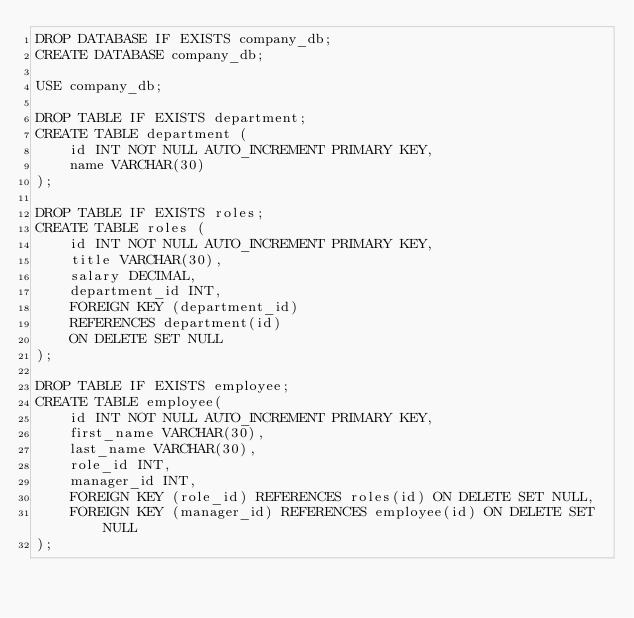<code> <loc_0><loc_0><loc_500><loc_500><_SQL_>DROP DATABASE IF EXISTS company_db;
CREATE DATABASE company_db;

USE company_db;

DROP TABLE IF EXISTS department;
CREATE TABLE department (
    id INT NOT NULL AUTO_INCREMENT PRIMARY KEY,
    name VARCHAR(30)
);

DROP TABLE IF EXISTS roles;
CREATE TABLE roles (
    id INT NOT NULL AUTO_INCREMENT PRIMARY KEY,
    title VARCHAR(30),
    salary DECIMAL,
    department_id INT,
    FOREIGN KEY (department_id)
    REFERENCES department(id)
    ON DELETE SET NULL
);

DROP TABLE IF EXISTS employee;
CREATE TABLE employee(
    id INT NOT NULL AUTO_INCREMENT PRIMARY KEY,
    first_name VARCHAR(30),
    last_name VARCHAR(30),
    role_id INT,
    manager_id INT,
    FOREIGN KEY (role_id) REFERENCES roles(id) ON DELETE SET NULL,
    FOREIGN KEY (manager_id) REFERENCES employee(id) ON DELETE SET NULL
);</code> 